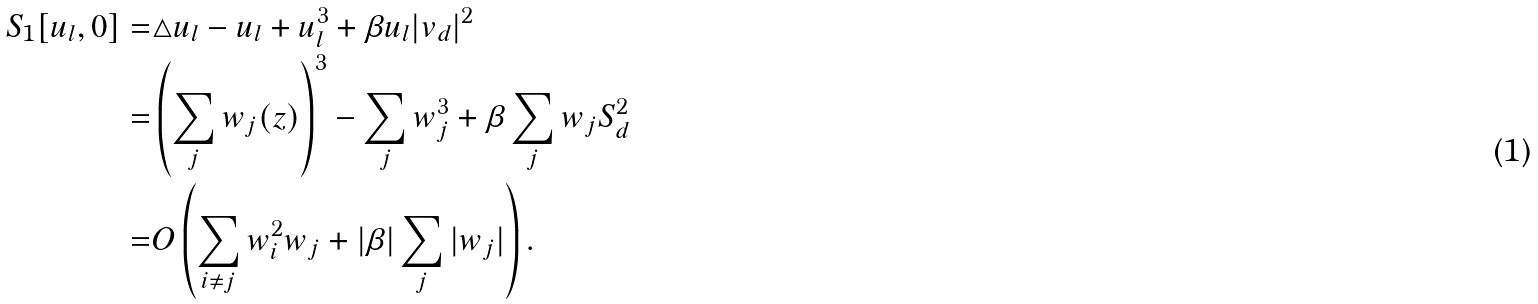<formula> <loc_0><loc_0><loc_500><loc_500>S _ { 1 } [ u _ { l } , 0 ] = & \triangle u _ { l } - u _ { l } + u _ { l } ^ { 3 } + \beta u _ { l } | v _ { d } | ^ { 2 } \\ = & \left ( \sum _ { j } w _ { j } ( z ) \right ) ^ { 3 } - \sum _ { j } w _ { j } ^ { 3 } + \beta \sum _ { j } w _ { j } S _ { d } ^ { 2 } \\ = & O \left ( \sum _ { i \neq j } w _ { i } ^ { 2 } w _ { j } + | \beta | \sum _ { j } | w _ { j } | \right ) .</formula> 